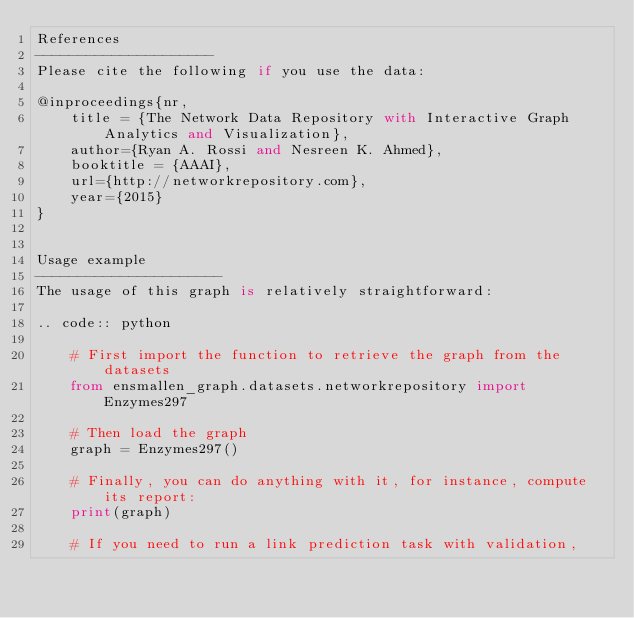<code> <loc_0><loc_0><loc_500><loc_500><_Python_>References
---------------------
Please cite the following if you use the data:

@inproceedings{nr,
    title = {The Network Data Repository with Interactive Graph Analytics and Visualization},
    author={Ryan A. Rossi and Nesreen K. Ahmed},
    booktitle = {AAAI},
    url={http://networkrepository.com},
    year={2015}
}


Usage example
----------------------
The usage of this graph is relatively straightforward:

.. code:: python

    # First import the function to retrieve the graph from the datasets
    from ensmallen_graph.datasets.networkrepository import Enzymes297

    # Then load the graph
    graph = Enzymes297()

    # Finally, you can do anything with it, for instance, compute its report:
    print(graph)

    # If you need to run a link prediction task with validation,</code> 